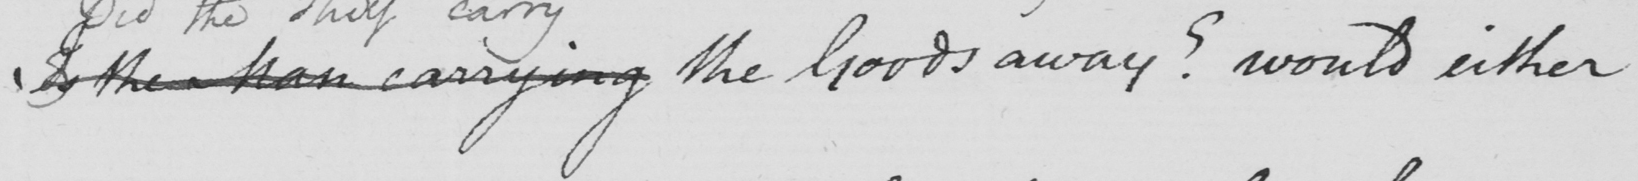Transcribe the text shown in this historical manuscript line. Is the Man carrying the Goods away ?  would either 